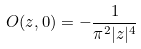Convert formula to latex. <formula><loc_0><loc_0><loc_500><loc_500>O ( z , 0 ) = - \frac { 1 } { \pi ^ { 2 } | z | ^ { 4 } }</formula> 